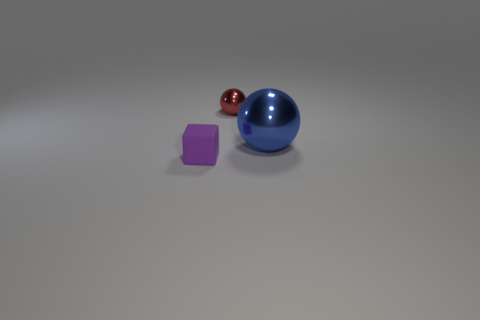There is a purple thing; is it the same size as the shiny sphere in front of the small red metallic ball?
Provide a succinct answer. No. There is a metallic ball that is right of the tiny thing to the right of the tiny thing in front of the blue ball; what size is it?
Keep it short and to the point. Large. There is a sphere in front of the tiny shiny ball; what size is it?
Your response must be concise. Large. The big thing that is the same material as the small red sphere is what shape?
Keep it short and to the point. Sphere. Is the material of the object that is to the left of the tiny metal object the same as the blue ball?
Provide a succinct answer. No. How many other objects are there of the same material as the cube?
Your response must be concise. 0. What number of objects are metal balls that are to the right of the small red metal sphere or things to the left of the big object?
Offer a terse response. 3. Does the shiny thing that is in front of the tiny red sphere have the same shape as the tiny object that is behind the small purple block?
Offer a very short reply. Yes. What shape is the red shiny object that is the same size as the purple object?
Your answer should be compact. Sphere. What number of matte objects are either large cyan balls or small red balls?
Ensure brevity in your answer.  0. 